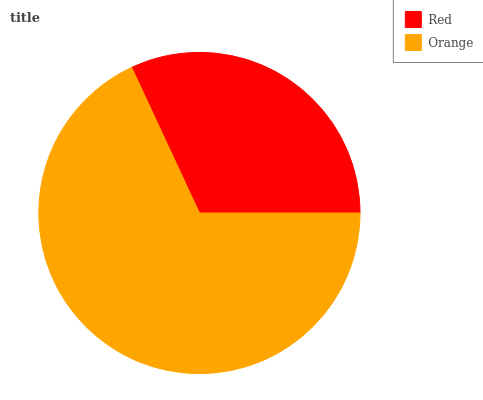Is Red the minimum?
Answer yes or no. Yes. Is Orange the maximum?
Answer yes or no. Yes. Is Orange the minimum?
Answer yes or no. No. Is Orange greater than Red?
Answer yes or no. Yes. Is Red less than Orange?
Answer yes or no. Yes. Is Red greater than Orange?
Answer yes or no. No. Is Orange less than Red?
Answer yes or no. No. Is Orange the high median?
Answer yes or no. Yes. Is Red the low median?
Answer yes or no. Yes. Is Red the high median?
Answer yes or no. No. Is Orange the low median?
Answer yes or no. No. 